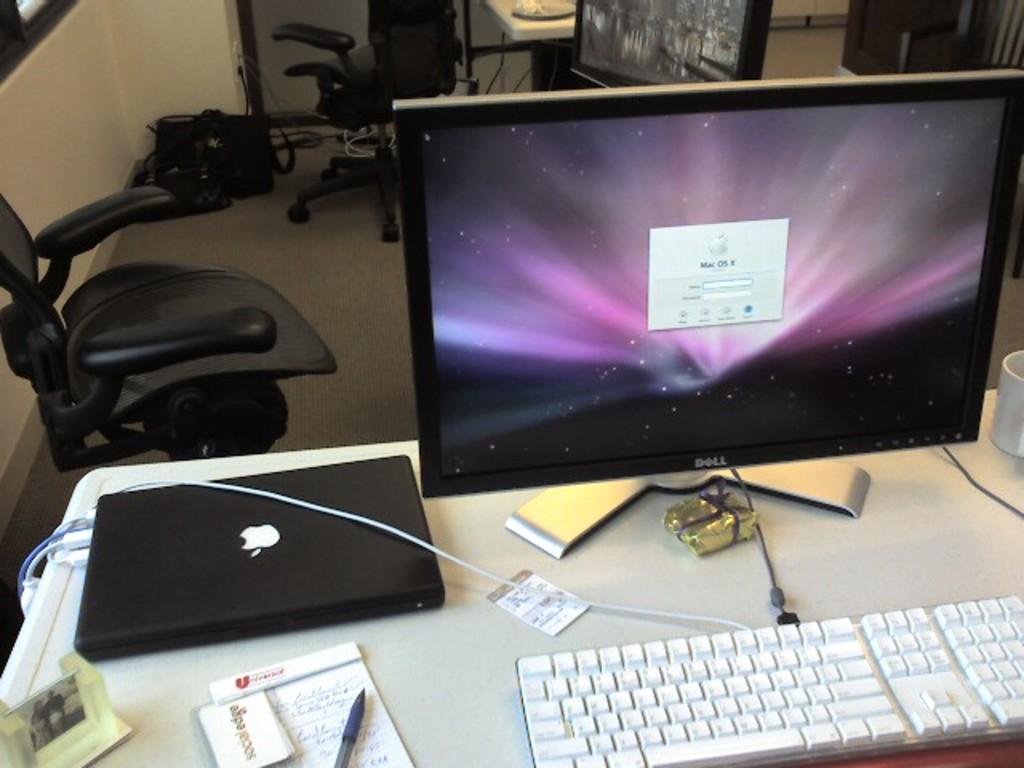What operating system is on the screen?
Provide a succinct answer. Mac os. 